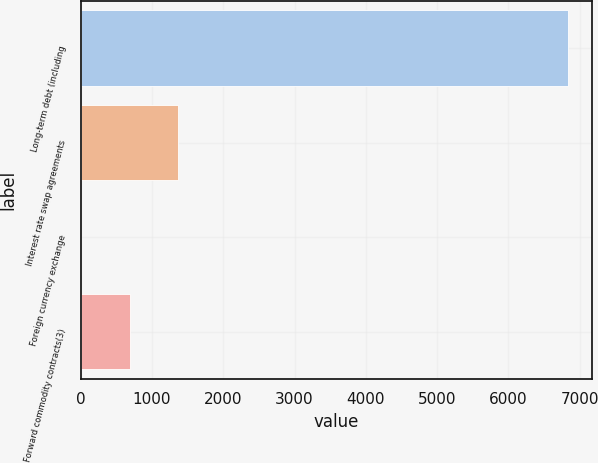Convert chart to OTSL. <chart><loc_0><loc_0><loc_500><loc_500><bar_chart><fcel>Long-term debt (including<fcel>Interest rate swap agreements<fcel>Foreign currency exchange<fcel>Forward commodity contracts(3)<nl><fcel>6835<fcel>1368.6<fcel>2<fcel>685.3<nl></chart> 